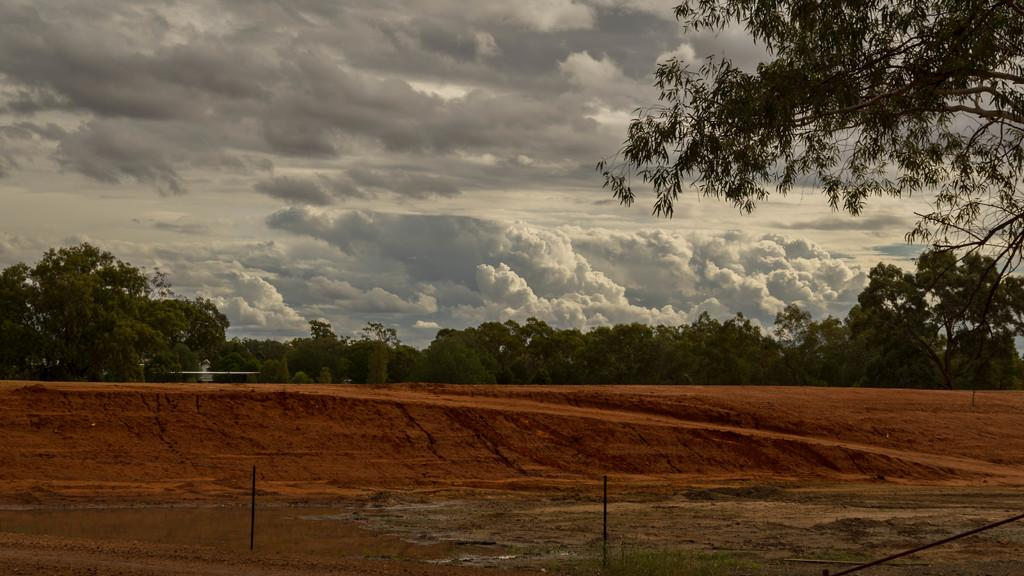What type of vegetation is visible in the image? There are many trees in the image. What is visible at the top of the image? The sky is visible at the top of the image. What can be seen in the sky? Clouds are present in the sky. What is located at the bottom of the image? There is a pole at the bottom of the image. What type of ground cover is visible at the bottom of the image? Grass is visible at the bottom of the image. Where is the card placed in the image? There is no card present in the image. What type of bird can be seen nesting in the trees in the image? There is no bird or nest visible in the image; only trees, sky, clouds, a pole, and grass are present. 